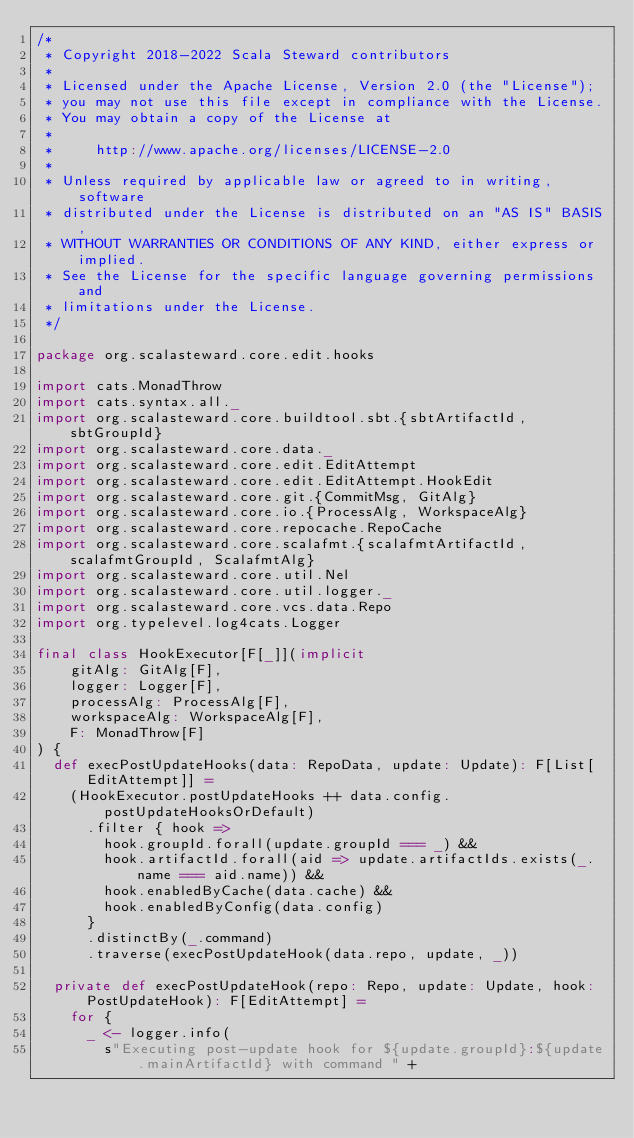<code> <loc_0><loc_0><loc_500><loc_500><_Scala_>/*
 * Copyright 2018-2022 Scala Steward contributors
 *
 * Licensed under the Apache License, Version 2.0 (the "License");
 * you may not use this file except in compliance with the License.
 * You may obtain a copy of the License at
 *
 *     http://www.apache.org/licenses/LICENSE-2.0
 *
 * Unless required by applicable law or agreed to in writing, software
 * distributed under the License is distributed on an "AS IS" BASIS,
 * WITHOUT WARRANTIES OR CONDITIONS OF ANY KIND, either express or implied.
 * See the License for the specific language governing permissions and
 * limitations under the License.
 */

package org.scalasteward.core.edit.hooks

import cats.MonadThrow
import cats.syntax.all._
import org.scalasteward.core.buildtool.sbt.{sbtArtifactId, sbtGroupId}
import org.scalasteward.core.data._
import org.scalasteward.core.edit.EditAttempt
import org.scalasteward.core.edit.EditAttempt.HookEdit
import org.scalasteward.core.git.{CommitMsg, GitAlg}
import org.scalasteward.core.io.{ProcessAlg, WorkspaceAlg}
import org.scalasteward.core.repocache.RepoCache
import org.scalasteward.core.scalafmt.{scalafmtArtifactId, scalafmtGroupId, ScalafmtAlg}
import org.scalasteward.core.util.Nel
import org.scalasteward.core.util.logger._
import org.scalasteward.core.vcs.data.Repo
import org.typelevel.log4cats.Logger

final class HookExecutor[F[_]](implicit
    gitAlg: GitAlg[F],
    logger: Logger[F],
    processAlg: ProcessAlg[F],
    workspaceAlg: WorkspaceAlg[F],
    F: MonadThrow[F]
) {
  def execPostUpdateHooks(data: RepoData, update: Update): F[List[EditAttempt]] =
    (HookExecutor.postUpdateHooks ++ data.config.postUpdateHooksOrDefault)
      .filter { hook =>
        hook.groupId.forall(update.groupId === _) &&
        hook.artifactId.forall(aid => update.artifactIds.exists(_.name === aid.name)) &&
        hook.enabledByCache(data.cache) &&
        hook.enabledByConfig(data.config)
      }
      .distinctBy(_.command)
      .traverse(execPostUpdateHook(data.repo, update, _))

  private def execPostUpdateHook(repo: Repo, update: Update, hook: PostUpdateHook): F[EditAttempt] =
    for {
      _ <- logger.info(
        s"Executing post-update hook for ${update.groupId}:${update.mainArtifactId} with command " +</code> 